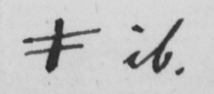Please provide the text content of this handwritten line. # it 